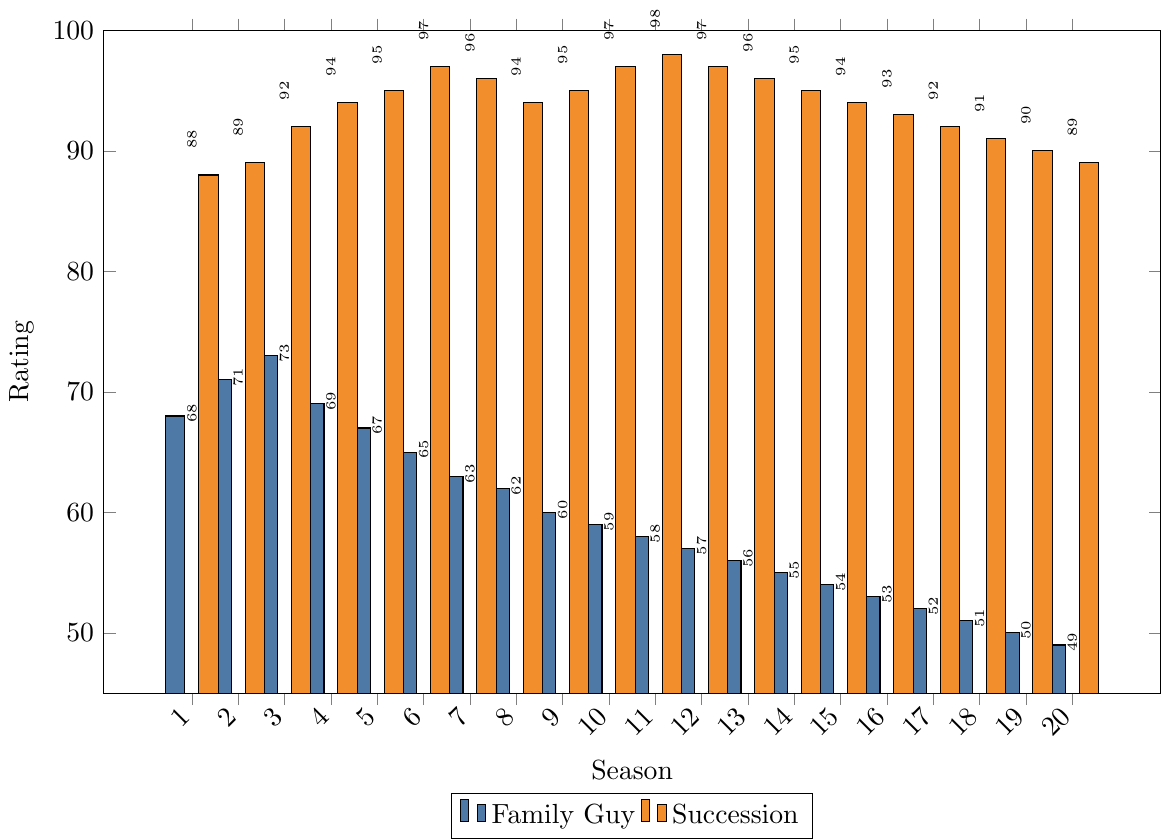what is the trend of Family Guy's ratings over the seasons? Looking at the height of the bars representing Family Guy's ratings, we notice a gradual downward trend from season 1 to season 20. Each bar becomes progressively shorter. Thus, we can conclude that Family Guy's ratings have declined over the seasons.
Answer: Downward How do the ratings of season 1 of Family Guy and Succession compare? The bar for Family Guy in season 1 is lower than the bar for Succession in season 1. Family Guy has a rating of 68 while Succession has 88. So, Succession's rating in season 1 is higher.
Answer: Succession's rating is higher What is the difference in ratings between the highest-rated season of Family Guy and the highest-rated season of Succession? The highest-rated season of Family Guy is season 3 with a rating of 73. The highest-rated season of Succession is season 11 with a rating of 98. The difference is 98 - 73 = 25.
Answer: 25 In which season(s) does Succession have a rating equal to or greater than 95? Looking at the bars for Succession, seasons with ratings equal to or greater than 95 are: 4 (94), 5 (95), 6 (97), 7 (96), 9 (95), 10 (97), 11 (98), 12 (97), and 13 (96).
Answer: 7 seasons: 5, 6, 7, 9, 10, 11, 12, 13 By how many points has the rating of Family Guy decreased from season 1 to season 20? The rating of Family Guy in season 1 is 68, and in season 20, it is 49. The decrease is calculated as 68 - 49 = 19.
Answer: 19 What is the average rating of Succession over all 20 seasons? To find the average rating of Succession, sum the ratings from all 20 seasons and divide by 20. The total sum is (88 + 89 + 92 + 94 + 95 + 97 + 96 + 94 + 95 + 97 + 98 + 97 + 96 + 95 + 94 + 93 + 92 + 91 + 90 + 89) = 1843. The average rating is 1843 / 20 = 92.15.
Answer: 92.15 Which show has more consistent ratings over the seasons? To determine consistency, we can look at the variation in the height of the bars over the seasons. Family Guy's ratings show more decline and irregularity, whereas Succession's ratings, while slightly fluctuating, remain generally higher and more stable around high values. Therefore, Succession has more consistent ratings.
Answer: Succession How much higher was Succession's rating compared to Family Guy's rating in season 10? Succession's rating in season 10 is 97, while Family Guy's rating in the same season is 59. The difference is calculated as 97 - 59 = 38.
Answer: 38 What is the overall rating trend of Succession from season 1 to season 20? Observing the heights of the bars that represent Succession's ratings, we find that ratings largely hover around higher values between 88 and 98, with a slight decrease towards season 20 but still remain high. The overall trend can be described as high and relatively stable with a slight downward trend near the end.
Answer: High and stable with slight downward trend 